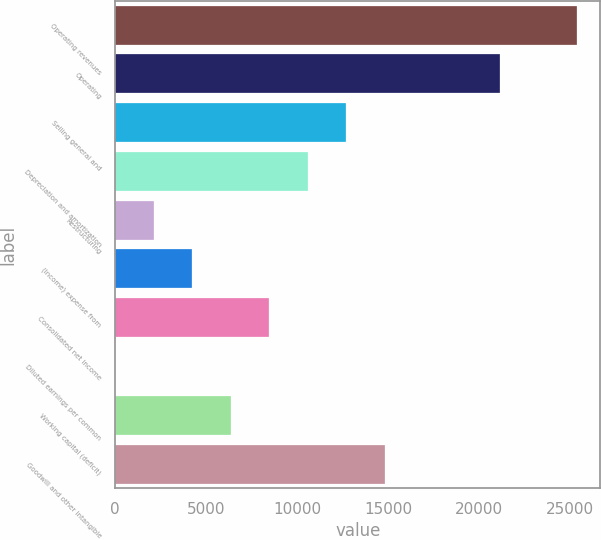Convert chart. <chart><loc_0><loc_0><loc_500><loc_500><bar_chart><fcel>Operating revenues<fcel>Operating<fcel>Selling general and<fcel>Depreciation and amortization<fcel>Restructuring<fcel>(Income) expense from<fcel>Consolidated net income<fcel>Diluted earnings per common<fcel>Working capital (deficit)<fcel>Goodwill and other intangible<nl><fcel>25384.4<fcel>21154<fcel>12693.2<fcel>10578<fcel>2117.21<fcel>4232.41<fcel>8462.81<fcel>2.01<fcel>6347.61<fcel>14808.4<nl></chart> 